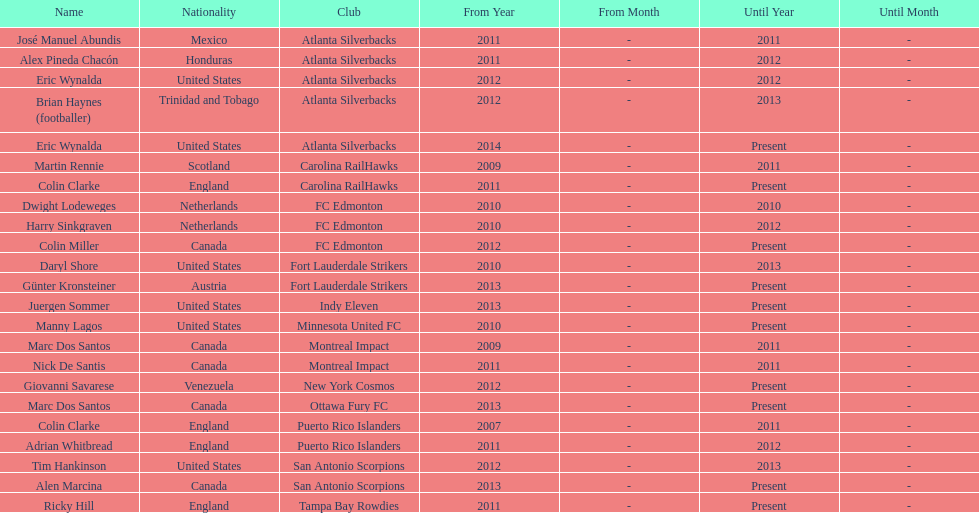How long did colin clarke coach the puerto rico islanders for? 4 years. 